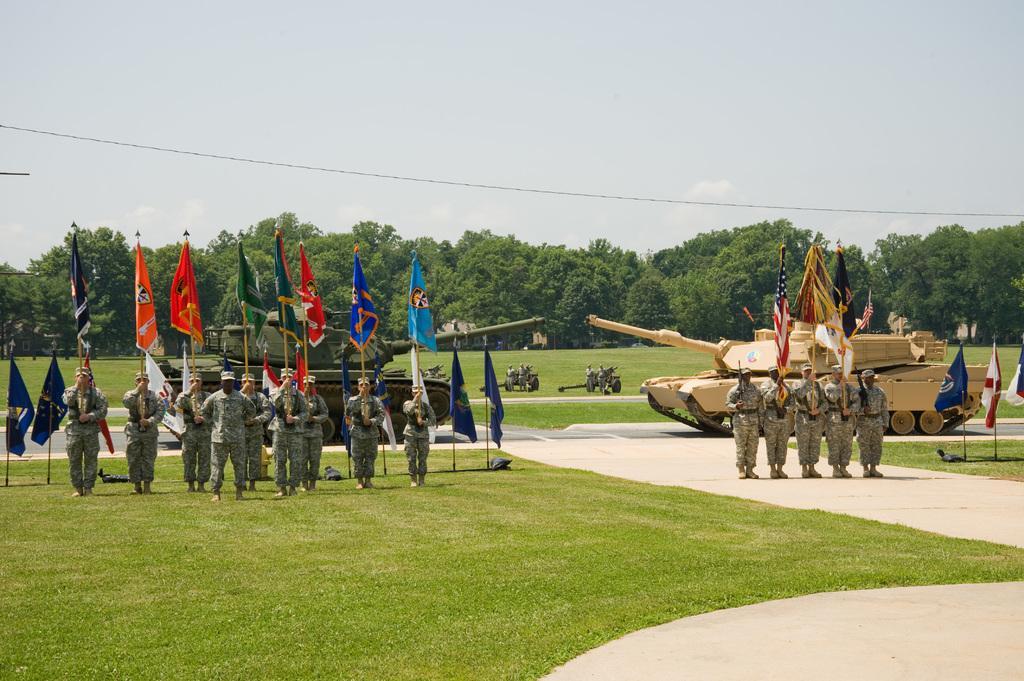Describe this image in one or two sentences. In this image there are soldiers holding flags in there hands, standing in a ground, in the background there are two machines and there are trees and a sky. 